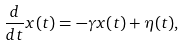<formula> <loc_0><loc_0><loc_500><loc_500>\frac { d } { d t } x ( t ) = - \gamma x ( t ) + \eta ( t ) ,</formula> 